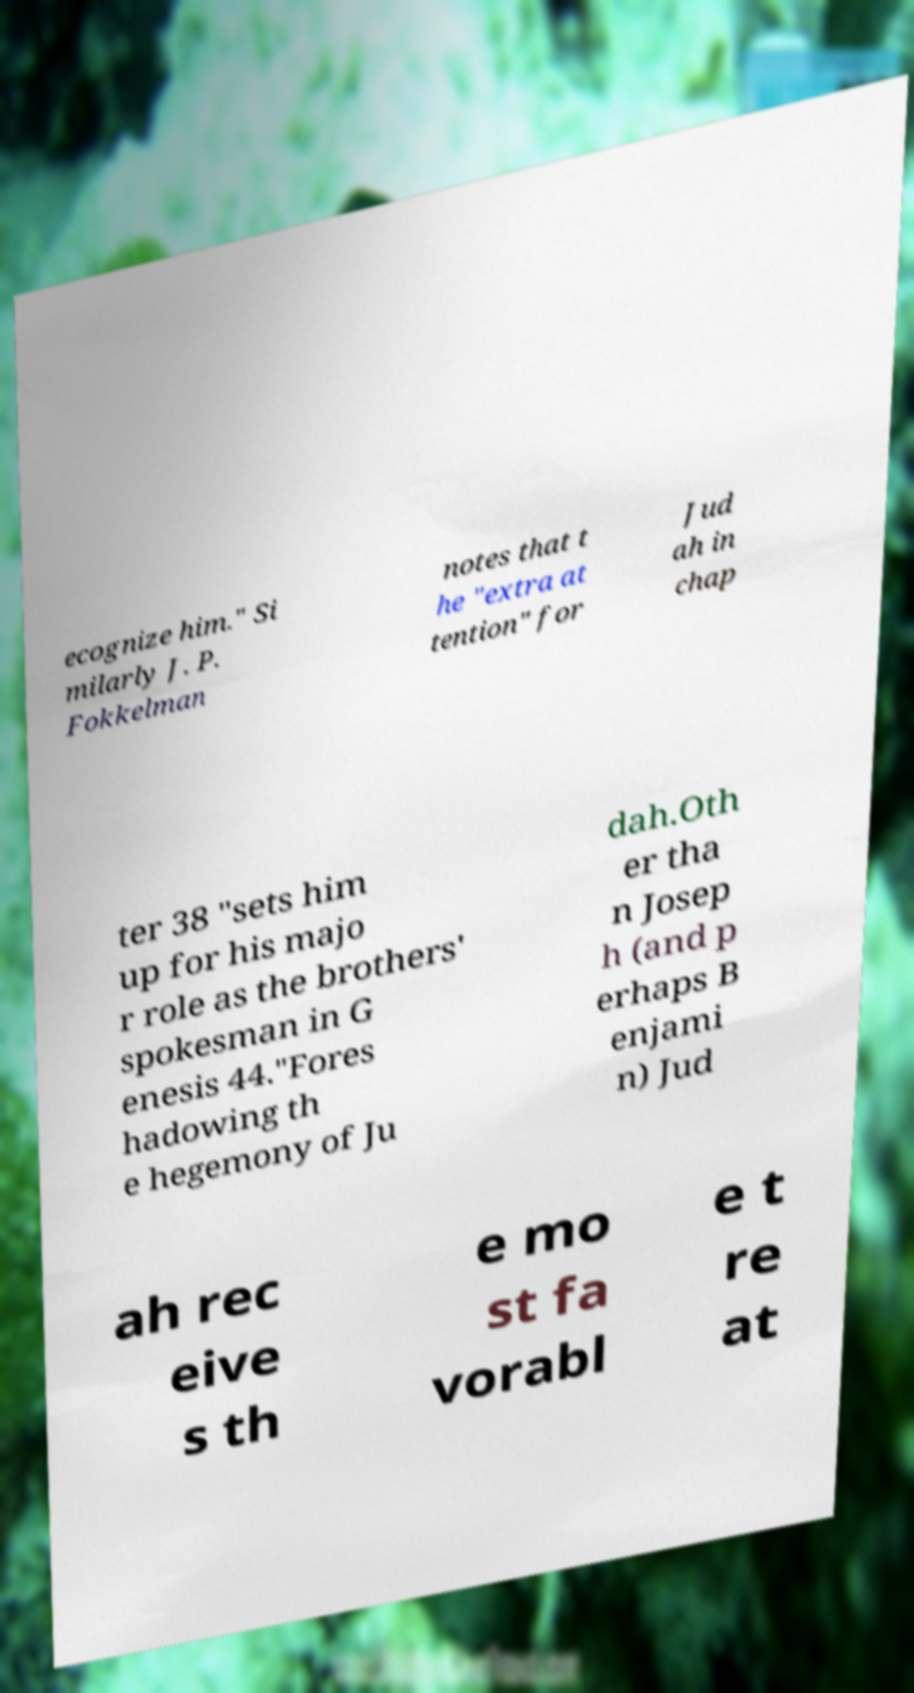I need the written content from this picture converted into text. Can you do that? ecognize him." Si milarly J. P. Fokkelman notes that t he "extra at tention" for Jud ah in chap ter 38 "sets him up for his majo r role as the brothers' spokesman in G enesis 44."Fores hadowing th e hegemony of Ju dah.Oth er tha n Josep h (and p erhaps B enjami n) Jud ah rec eive s th e mo st fa vorabl e t re at 